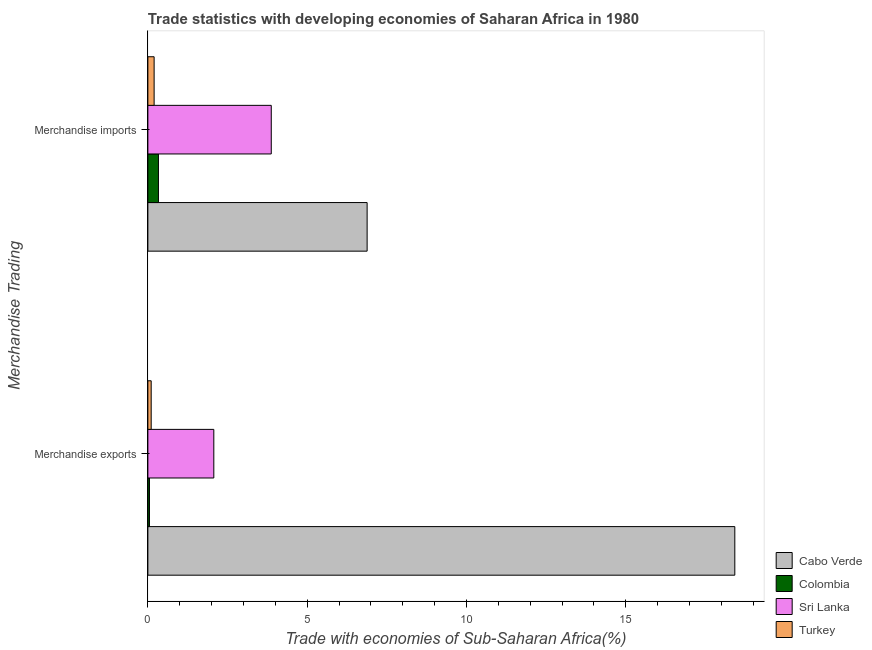How many different coloured bars are there?
Offer a very short reply. 4. Are the number of bars per tick equal to the number of legend labels?
Provide a short and direct response. Yes. Are the number of bars on each tick of the Y-axis equal?
Your response must be concise. Yes. How many bars are there on the 2nd tick from the top?
Keep it short and to the point. 4. What is the label of the 2nd group of bars from the top?
Make the answer very short. Merchandise exports. What is the merchandise imports in Cabo Verde?
Make the answer very short. 6.88. Across all countries, what is the maximum merchandise imports?
Offer a very short reply. 6.88. Across all countries, what is the minimum merchandise exports?
Ensure brevity in your answer.  0.05. In which country was the merchandise imports maximum?
Your answer should be very brief. Cabo Verde. What is the total merchandise exports in the graph?
Provide a succinct answer. 20.65. What is the difference between the merchandise imports in Colombia and that in Turkey?
Provide a short and direct response. 0.14. What is the difference between the merchandise exports in Cabo Verde and the merchandise imports in Turkey?
Ensure brevity in your answer.  18.22. What is the average merchandise imports per country?
Provide a short and direct response. 2.82. What is the difference between the merchandise exports and merchandise imports in Colombia?
Offer a terse response. -0.28. What is the ratio of the merchandise exports in Cabo Verde to that in Turkey?
Provide a succinct answer. 177.14. In how many countries, is the merchandise exports greater than the average merchandise exports taken over all countries?
Provide a short and direct response. 1. What does the 4th bar from the bottom in Merchandise exports represents?
Your answer should be compact. Turkey. Are all the bars in the graph horizontal?
Make the answer very short. Yes. How many countries are there in the graph?
Make the answer very short. 4. What is the difference between two consecutive major ticks on the X-axis?
Your response must be concise. 5. What is the title of the graph?
Offer a terse response. Trade statistics with developing economies of Saharan Africa in 1980. Does "Central African Republic" appear as one of the legend labels in the graph?
Keep it short and to the point. No. What is the label or title of the X-axis?
Your response must be concise. Trade with economies of Sub-Saharan Africa(%). What is the label or title of the Y-axis?
Your response must be concise. Merchandise Trading. What is the Trade with economies of Sub-Saharan Africa(%) in Cabo Verde in Merchandise exports?
Offer a terse response. 18.42. What is the Trade with economies of Sub-Saharan Africa(%) of Colombia in Merchandise exports?
Make the answer very short. 0.05. What is the Trade with economies of Sub-Saharan Africa(%) in Sri Lanka in Merchandise exports?
Your response must be concise. 2.07. What is the Trade with economies of Sub-Saharan Africa(%) of Turkey in Merchandise exports?
Give a very brief answer. 0.1. What is the Trade with economies of Sub-Saharan Africa(%) of Cabo Verde in Merchandise imports?
Make the answer very short. 6.88. What is the Trade with economies of Sub-Saharan Africa(%) of Colombia in Merchandise imports?
Ensure brevity in your answer.  0.33. What is the Trade with economies of Sub-Saharan Africa(%) of Sri Lanka in Merchandise imports?
Make the answer very short. 3.87. What is the Trade with economies of Sub-Saharan Africa(%) in Turkey in Merchandise imports?
Your answer should be compact. 0.2. Across all Merchandise Trading, what is the maximum Trade with economies of Sub-Saharan Africa(%) in Cabo Verde?
Your answer should be very brief. 18.42. Across all Merchandise Trading, what is the maximum Trade with economies of Sub-Saharan Africa(%) of Colombia?
Offer a terse response. 0.33. Across all Merchandise Trading, what is the maximum Trade with economies of Sub-Saharan Africa(%) in Sri Lanka?
Your answer should be very brief. 3.87. Across all Merchandise Trading, what is the maximum Trade with economies of Sub-Saharan Africa(%) of Turkey?
Your answer should be very brief. 0.2. Across all Merchandise Trading, what is the minimum Trade with economies of Sub-Saharan Africa(%) of Cabo Verde?
Provide a short and direct response. 6.88. Across all Merchandise Trading, what is the minimum Trade with economies of Sub-Saharan Africa(%) in Colombia?
Give a very brief answer. 0.05. Across all Merchandise Trading, what is the minimum Trade with economies of Sub-Saharan Africa(%) of Sri Lanka?
Provide a succinct answer. 2.07. Across all Merchandise Trading, what is the minimum Trade with economies of Sub-Saharan Africa(%) in Turkey?
Your response must be concise. 0.1. What is the total Trade with economies of Sub-Saharan Africa(%) of Cabo Verde in the graph?
Keep it short and to the point. 25.3. What is the total Trade with economies of Sub-Saharan Africa(%) in Colombia in the graph?
Make the answer very short. 0.38. What is the total Trade with economies of Sub-Saharan Africa(%) of Sri Lanka in the graph?
Make the answer very short. 5.94. What is the total Trade with economies of Sub-Saharan Africa(%) of Turkey in the graph?
Ensure brevity in your answer.  0.3. What is the difference between the Trade with economies of Sub-Saharan Africa(%) in Cabo Verde in Merchandise exports and that in Merchandise imports?
Offer a very short reply. 11.54. What is the difference between the Trade with economies of Sub-Saharan Africa(%) in Colombia in Merchandise exports and that in Merchandise imports?
Offer a terse response. -0.28. What is the difference between the Trade with economies of Sub-Saharan Africa(%) of Sri Lanka in Merchandise exports and that in Merchandise imports?
Make the answer very short. -1.8. What is the difference between the Trade with economies of Sub-Saharan Africa(%) of Turkey in Merchandise exports and that in Merchandise imports?
Keep it short and to the point. -0.09. What is the difference between the Trade with economies of Sub-Saharan Africa(%) in Cabo Verde in Merchandise exports and the Trade with economies of Sub-Saharan Africa(%) in Colombia in Merchandise imports?
Offer a terse response. 18.09. What is the difference between the Trade with economies of Sub-Saharan Africa(%) in Cabo Verde in Merchandise exports and the Trade with economies of Sub-Saharan Africa(%) in Sri Lanka in Merchandise imports?
Keep it short and to the point. 14.55. What is the difference between the Trade with economies of Sub-Saharan Africa(%) in Cabo Verde in Merchandise exports and the Trade with economies of Sub-Saharan Africa(%) in Turkey in Merchandise imports?
Keep it short and to the point. 18.22. What is the difference between the Trade with economies of Sub-Saharan Africa(%) in Colombia in Merchandise exports and the Trade with economies of Sub-Saharan Africa(%) in Sri Lanka in Merchandise imports?
Keep it short and to the point. -3.82. What is the difference between the Trade with economies of Sub-Saharan Africa(%) in Colombia in Merchandise exports and the Trade with economies of Sub-Saharan Africa(%) in Turkey in Merchandise imports?
Offer a terse response. -0.15. What is the difference between the Trade with economies of Sub-Saharan Africa(%) of Sri Lanka in Merchandise exports and the Trade with economies of Sub-Saharan Africa(%) of Turkey in Merchandise imports?
Provide a short and direct response. 1.87. What is the average Trade with economies of Sub-Saharan Africa(%) of Cabo Verde per Merchandise Trading?
Make the answer very short. 12.65. What is the average Trade with economies of Sub-Saharan Africa(%) of Colombia per Merchandise Trading?
Your answer should be very brief. 0.19. What is the average Trade with economies of Sub-Saharan Africa(%) in Sri Lanka per Merchandise Trading?
Provide a succinct answer. 2.97. What is the average Trade with economies of Sub-Saharan Africa(%) of Turkey per Merchandise Trading?
Offer a terse response. 0.15. What is the difference between the Trade with economies of Sub-Saharan Africa(%) in Cabo Verde and Trade with economies of Sub-Saharan Africa(%) in Colombia in Merchandise exports?
Make the answer very short. 18.37. What is the difference between the Trade with economies of Sub-Saharan Africa(%) of Cabo Verde and Trade with economies of Sub-Saharan Africa(%) of Sri Lanka in Merchandise exports?
Offer a very short reply. 16.35. What is the difference between the Trade with economies of Sub-Saharan Africa(%) in Cabo Verde and Trade with economies of Sub-Saharan Africa(%) in Turkey in Merchandise exports?
Offer a very short reply. 18.32. What is the difference between the Trade with economies of Sub-Saharan Africa(%) of Colombia and Trade with economies of Sub-Saharan Africa(%) of Sri Lanka in Merchandise exports?
Your response must be concise. -2.02. What is the difference between the Trade with economies of Sub-Saharan Africa(%) of Colombia and Trade with economies of Sub-Saharan Africa(%) of Turkey in Merchandise exports?
Provide a short and direct response. -0.05. What is the difference between the Trade with economies of Sub-Saharan Africa(%) in Sri Lanka and Trade with economies of Sub-Saharan Africa(%) in Turkey in Merchandise exports?
Offer a very short reply. 1.97. What is the difference between the Trade with economies of Sub-Saharan Africa(%) in Cabo Verde and Trade with economies of Sub-Saharan Africa(%) in Colombia in Merchandise imports?
Make the answer very short. 6.55. What is the difference between the Trade with economies of Sub-Saharan Africa(%) of Cabo Verde and Trade with economies of Sub-Saharan Africa(%) of Sri Lanka in Merchandise imports?
Make the answer very short. 3.01. What is the difference between the Trade with economies of Sub-Saharan Africa(%) in Cabo Verde and Trade with economies of Sub-Saharan Africa(%) in Turkey in Merchandise imports?
Your answer should be compact. 6.68. What is the difference between the Trade with economies of Sub-Saharan Africa(%) of Colombia and Trade with economies of Sub-Saharan Africa(%) of Sri Lanka in Merchandise imports?
Provide a succinct answer. -3.54. What is the difference between the Trade with economies of Sub-Saharan Africa(%) of Colombia and Trade with economies of Sub-Saharan Africa(%) of Turkey in Merchandise imports?
Give a very brief answer. 0.14. What is the difference between the Trade with economies of Sub-Saharan Africa(%) in Sri Lanka and Trade with economies of Sub-Saharan Africa(%) in Turkey in Merchandise imports?
Give a very brief answer. 3.68. What is the ratio of the Trade with economies of Sub-Saharan Africa(%) in Cabo Verde in Merchandise exports to that in Merchandise imports?
Provide a short and direct response. 2.68. What is the ratio of the Trade with economies of Sub-Saharan Africa(%) in Colombia in Merchandise exports to that in Merchandise imports?
Give a very brief answer. 0.15. What is the ratio of the Trade with economies of Sub-Saharan Africa(%) in Sri Lanka in Merchandise exports to that in Merchandise imports?
Offer a very short reply. 0.53. What is the ratio of the Trade with economies of Sub-Saharan Africa(%) of Turkey in Merchandise exports to that in Merchandise imports?
Offer a terse response. 0.53. What is the difference between the highest and the second highest Trade with economies of Sub-Saharan Africa(%) of Cabo Verde?
Offer a terse response. 11.54. What is the difference between the highest and the second highest Trade with economies of Sub-Saharan Africa(%) in Colombia?
Keep it short and to the point. 0.28. What is the difference between the highest and the second highest Trade with economies of Sub-Saharan Africa(%) of Sri Lanka?
Ensure brevity in your answer.  1.8. What is the difference between the highest and the second highest Trade with economies of Sub-Saharan Africa(%) of Turkey?
Ensure brevity in your answer.  0.09. What is the difference between the highest and the lowest Trade with economies of Sub-Saharan Africa(%) in Cabo Verde?
Ensure brevity in your answer.  11.54. What is the difference between the highest and the lowest Trade with economies of Sub-Saharan Africa(%) in Colombia?
Make the answer very short. 0.28. What is the difference between the highest and the lowest Trade with economies of Sub-Saharan Africa(%) of Sri Lanka?
Your answer should be compact. 1.8. What is the difference between the highest and the lowest Trade with economies of Sub-Saharan Africa(%) of Turkey?
Offer a terse response. 0.09. 